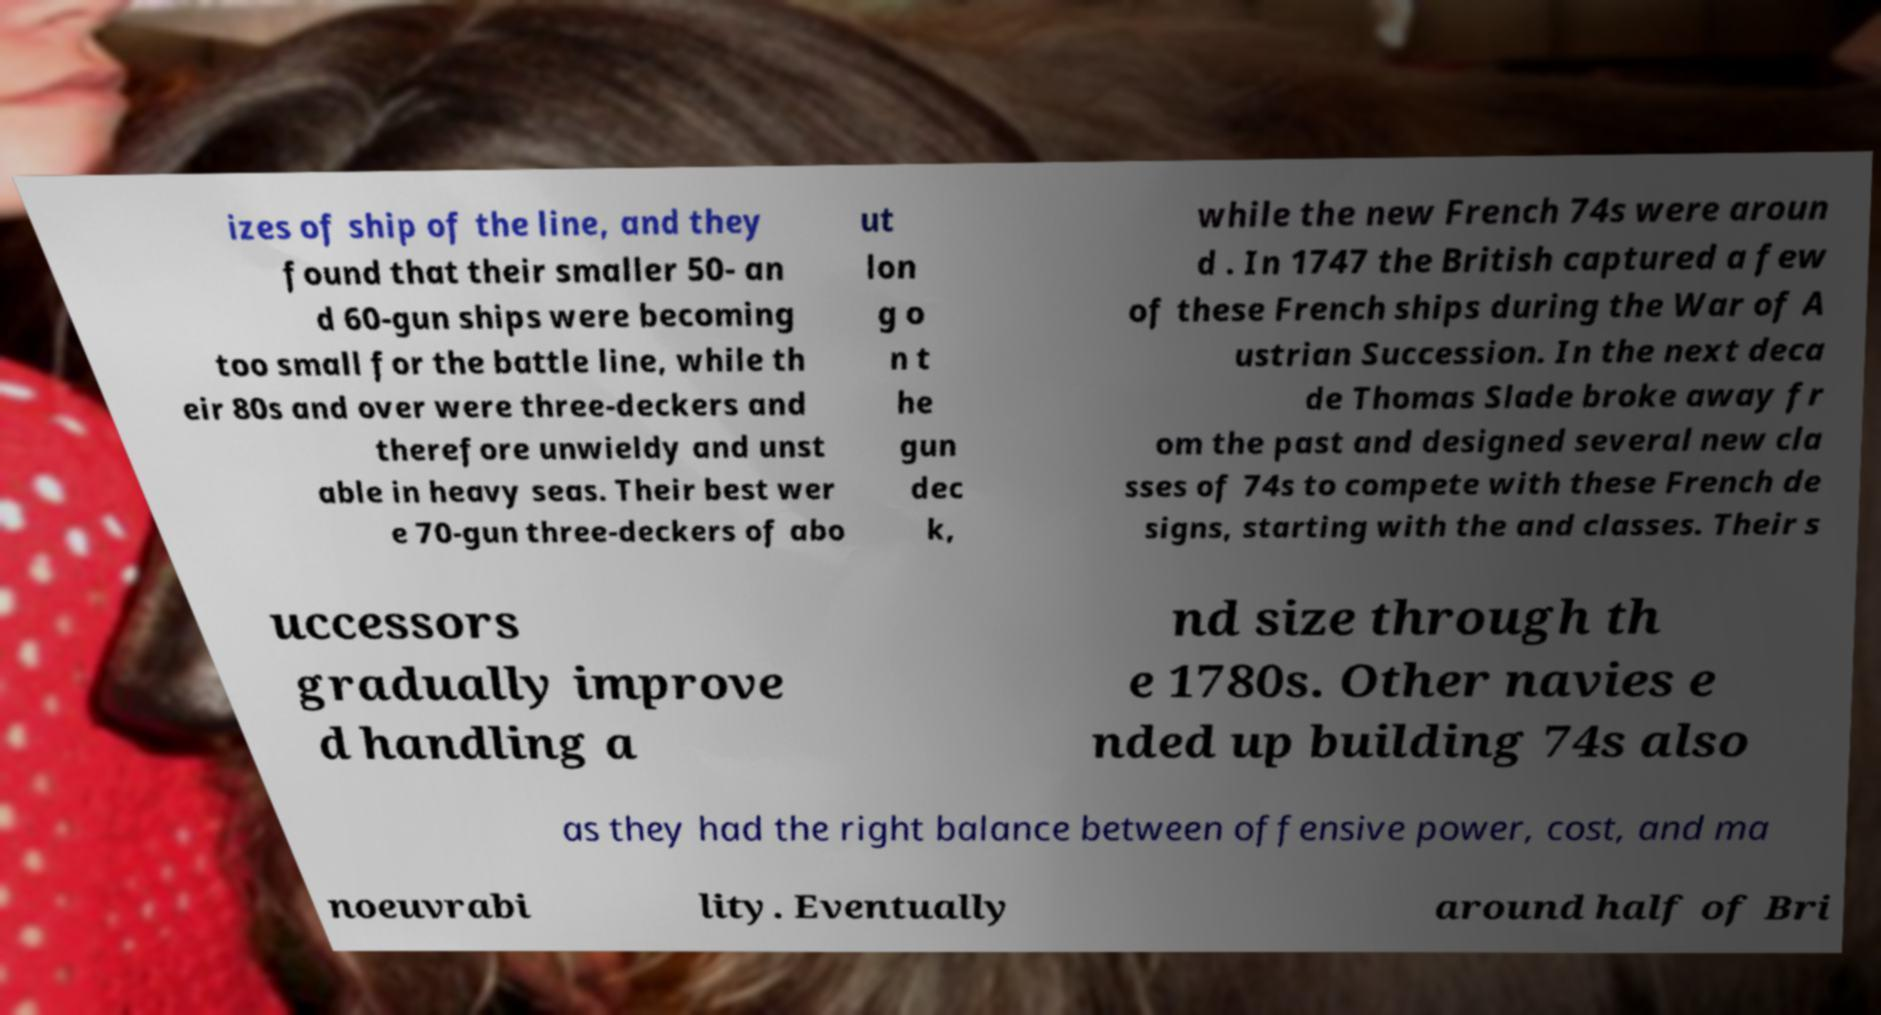Could you assist in decoding the text presented in this image and type it out clearly? izes of ship of the line, and they found that their smaller 50- an d 60-gun ships were becoming too small for the battle line, while th eir 80s and over were three-deckers and therefore unwieldy and unst able in heavy seas. Their best wer e 70-gun three-deckers of abo ut lon g o n t he gun dec k, while the new French 74s were aroun d . In 1747 the British captured a few of these French ships during the War of A ustrian Succession. In the next deca de Thomas Slade broke away fr om the past and designed several new cla sses of 74s to compete with these French de signs, starting with the and classes. Their s uccessors gradually improve d handling a nd size through th e 1780s. Other navies e nded up building 74s also as they had the right balance between offensive power, cost, and ma noeuvrabi lity. Eventually around half of Bri 